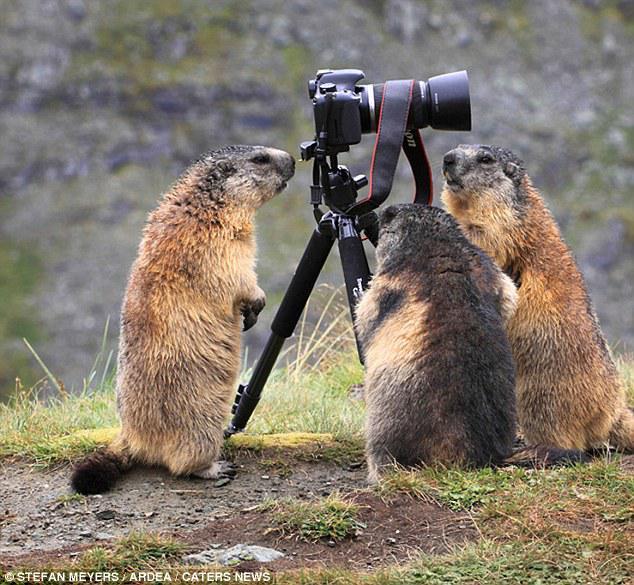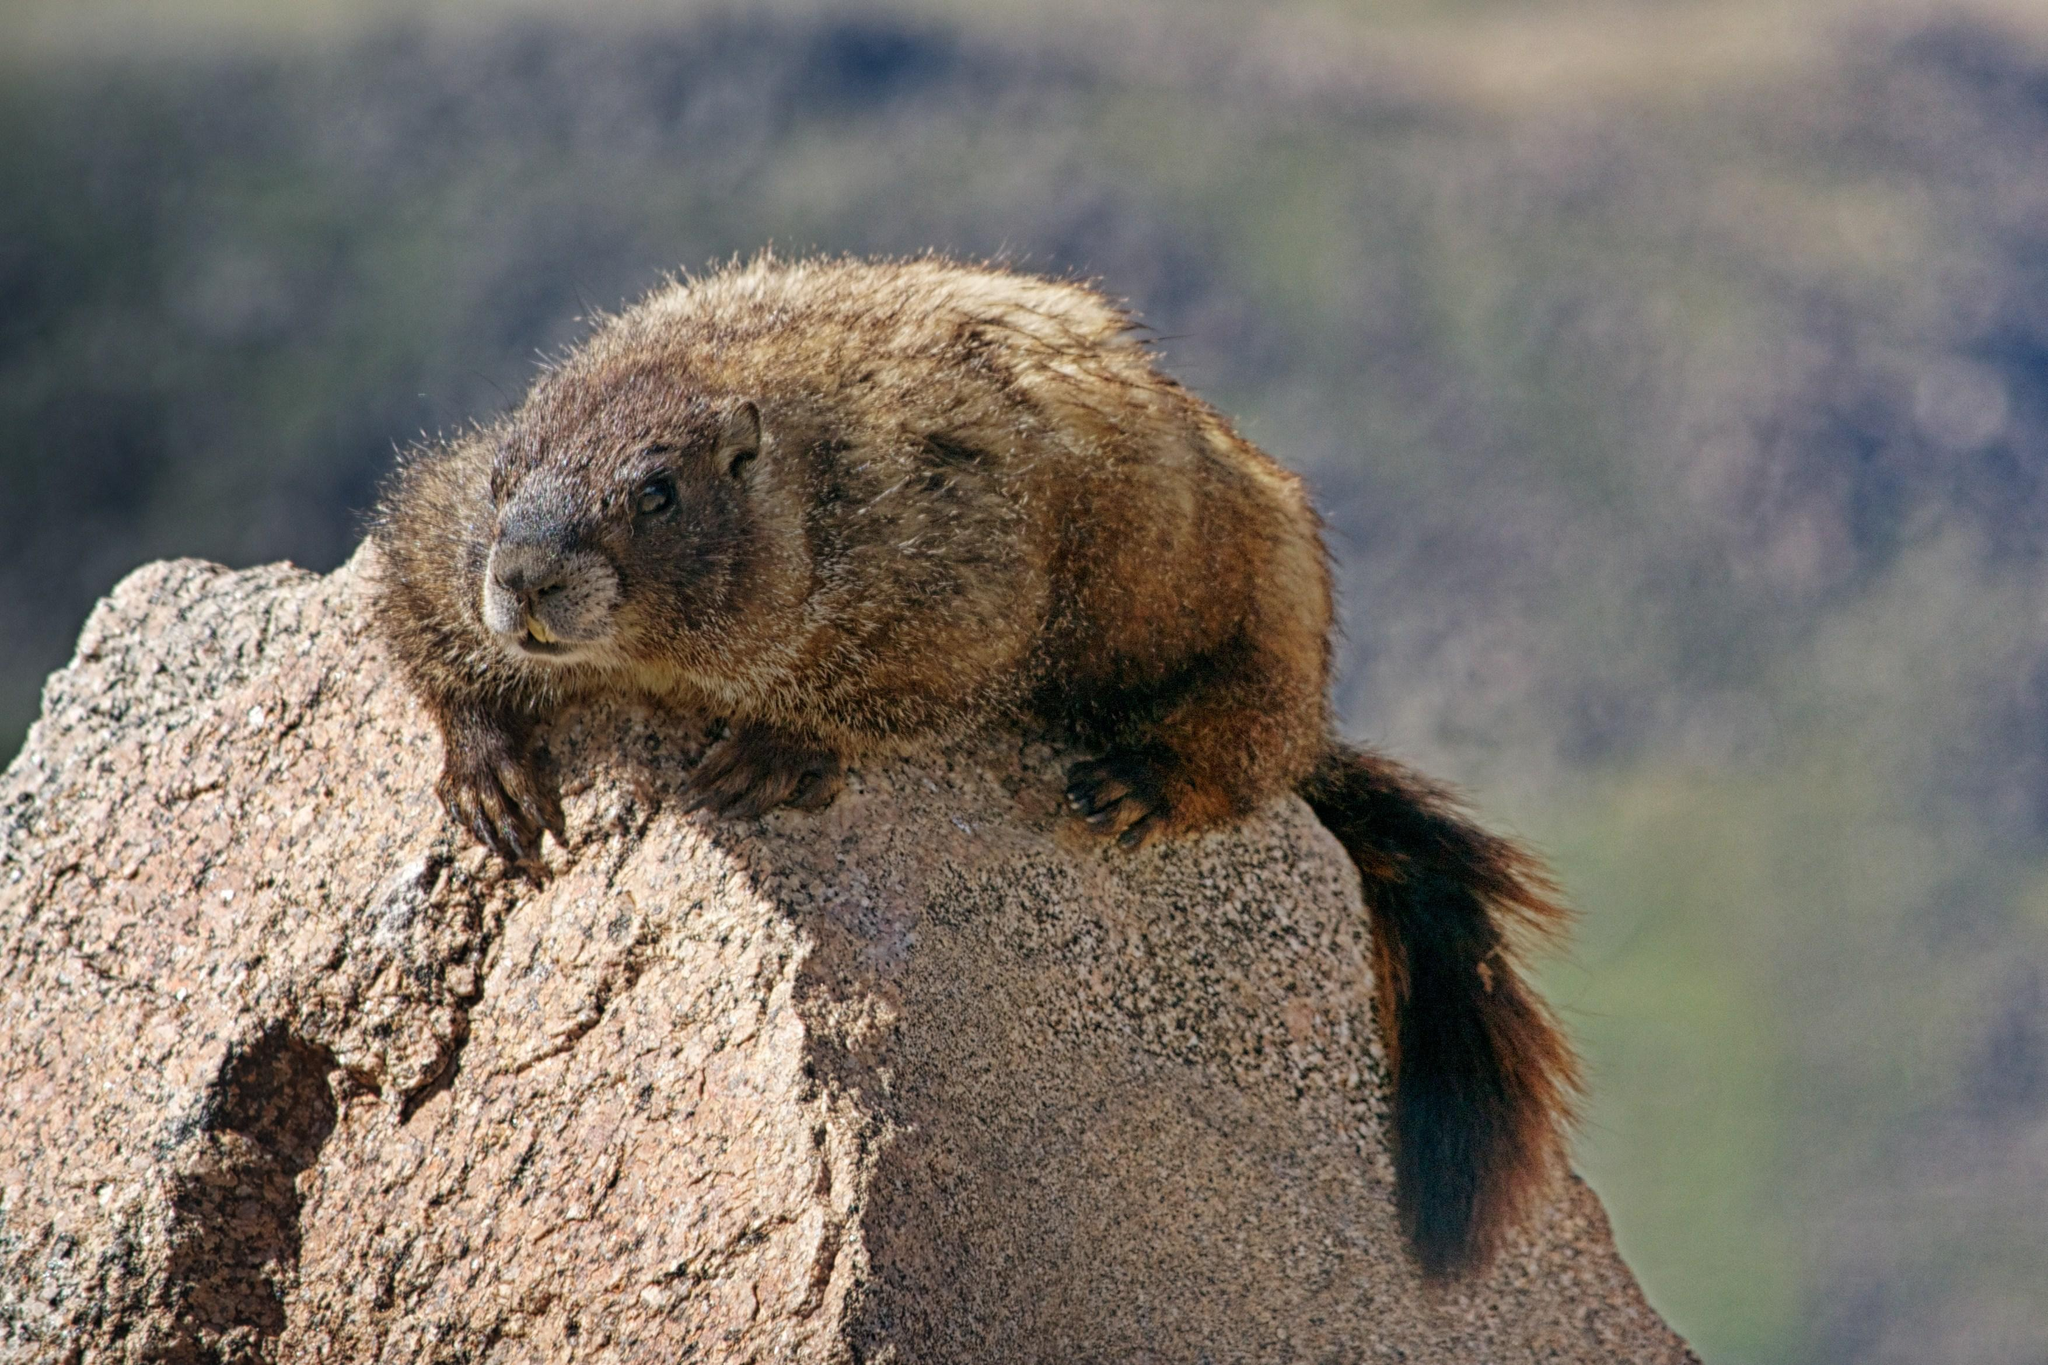The first image is the image on the left, the second image is the image on the right. Examine the images to the left and right. Is the description "There are only 2 marmots." accurate? Answer yes or no. No. 